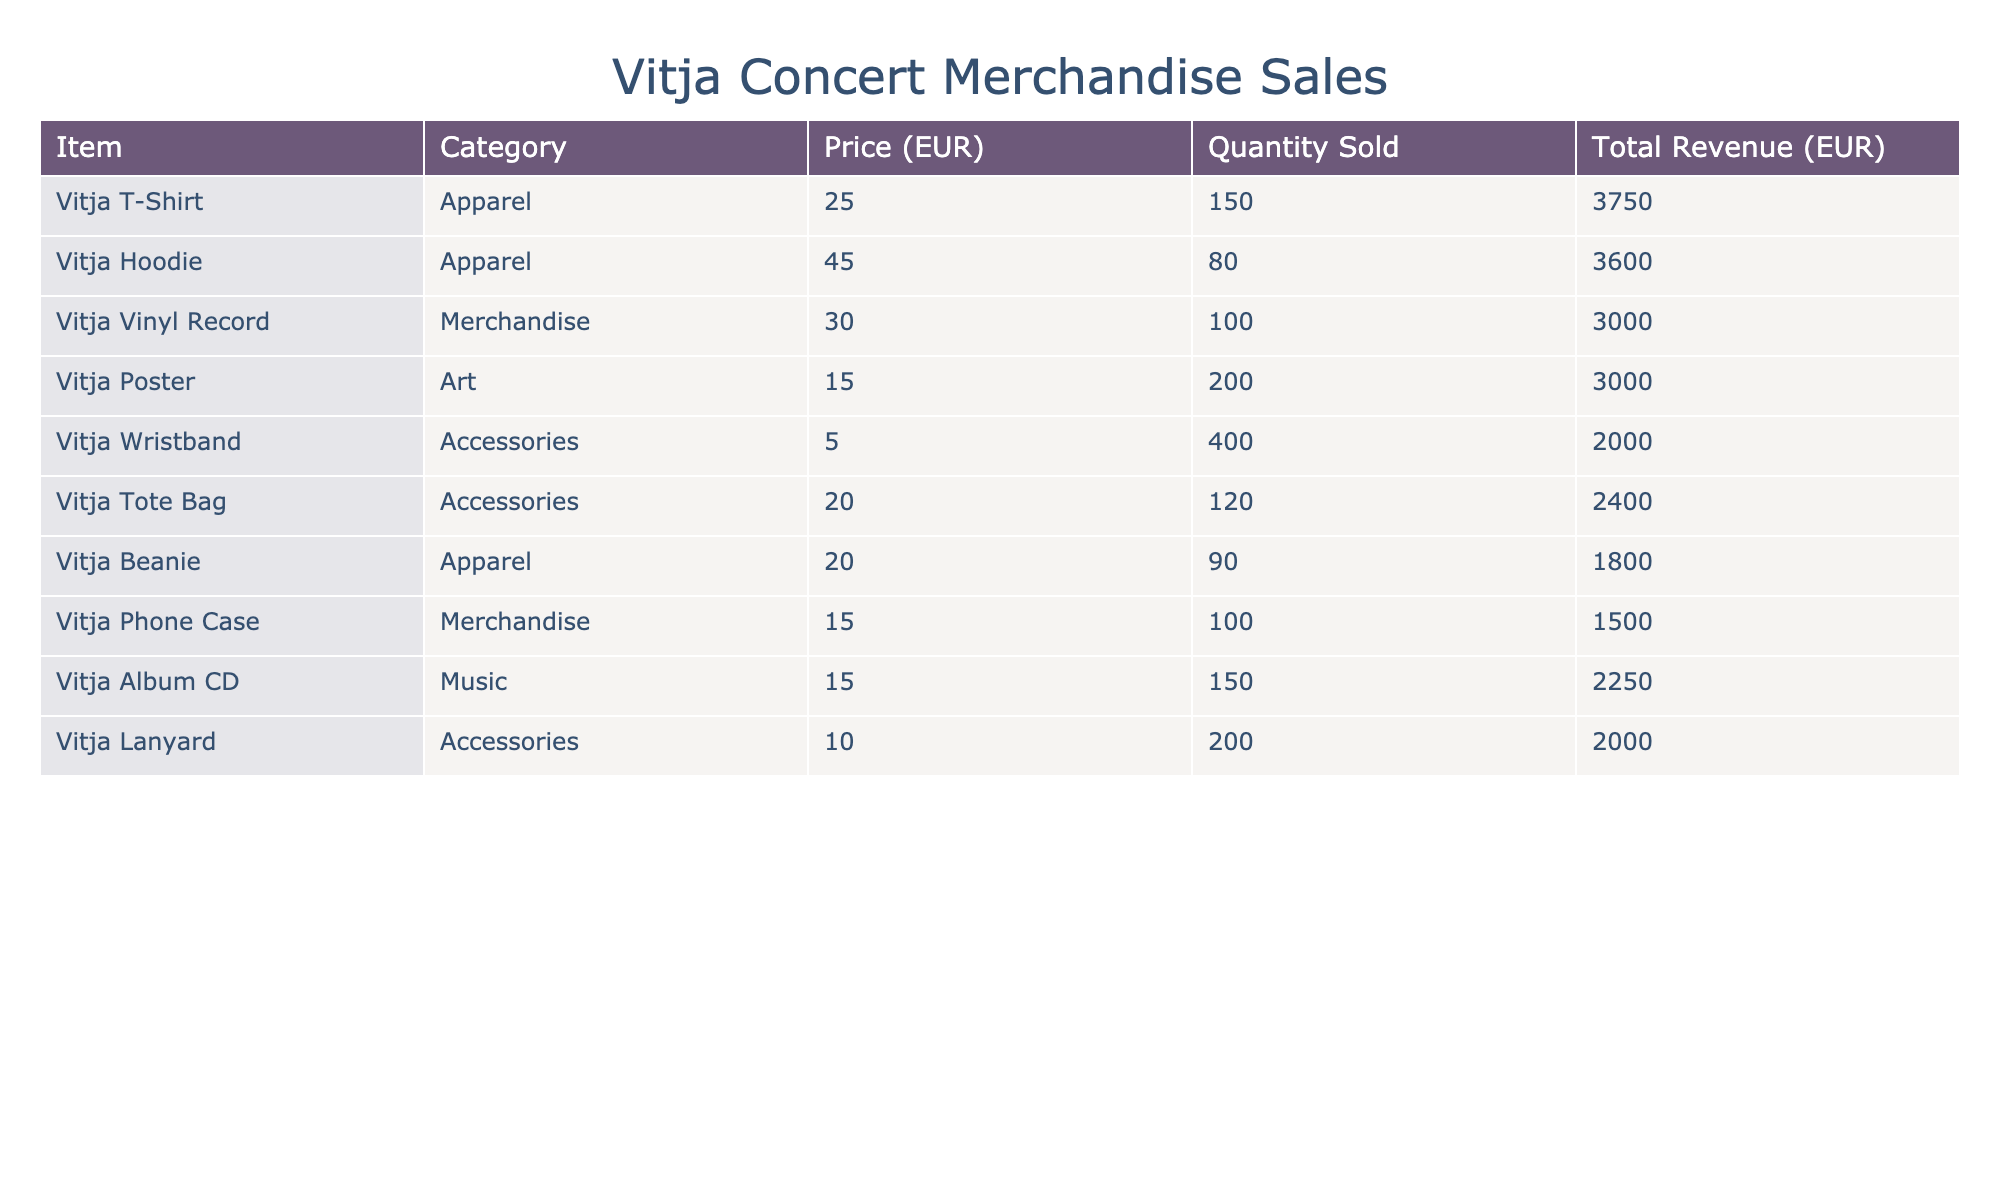What is the total revenue generated from the sale of Vitja Hoodies? The table shows that the quantity sold for Vitja Hoodies is 80 and the price per hoodie is 45 EUR. To calculate the total revenue: 80 x 45 = 3600 EUR.
Answer: 3600 EUR Which merchandise item had the highest quantity sold? By examining the quantity sold, the Vitja Wristband has the highest quantity at 400.
Answer: Vitja Wristband What is the total revenue from all Accessories sold? The revenue from Accessories items are: Vitja Wristband (2000 EUR), Vitja Tote Bag (2400 EUR), and Vitja Lanyard (2000 EUR). Adding them together: 2000 + 2400 + 2000 = 6400 EUR.
Answer: 6400 EUR Did the sales of Vitja Vinyl Records exceed the sales of Vitja Phone Cases? The total revenue from the sales of Vitja Vinyl Records is 3000 EUR, and for Vitja Phone Cases it is 1500 EUR. Since 3000 > 1500, therefore the sales of Vinyl Records did exceed those of Phone Cases.
Answer: Yes What is the average price of the Apparel items sold? The Apparel items in the table are: Vitja T-Shirt (25 EUR), Vitja Hoodie (45 EUR), and Vitja Beanie (20 EUR). The total price is 25 + 45 + 20 = 90 EUR. The average price is calculated as 90 / 3 = 30 EUR.
Answer: 30 EUR How much revenue was generated from the sale of Art merchandise? The only Art merchandise listed is the Vitja Poster, which has a total revenue of 3000 EUR from the sales of 200 posters at 15 EUR each.
Answer: 3000 EUR Which category had the lowest total revenue, and what was that amount? The total revenue for each category can be checked by calculating them. The lowest is Accessories with a total of 6400 EUR (2000 + 2400 + 2000), but comparing to others, Merchandise (3000) is lower, so it is the lowest category.
Answer: Merchandise, 3000 EUR If all categories' revenues were to be summed, what would the total revenue be? The total revenues from all categories are: 3750 (Apparel) + 3600 (Apparel) + 3000 (Merchandise) + 3000 (Art) + 2000 (Accessories) + 2400 (Accessories) + 1800 (Apparel) + 1500 (Merchandise) + 2250 (Music) + 2000 (Accessories) = 26500 EUR. Thus the total revenue is 26500 EUR.
Answer: 26500 EUR How many more units of Vitja Wristbands were sold compared to Vitja Beanies? The Quantity sold for Vitja Wristbands is 400 and for Vitja Beanies is 90. To find the difference: 400 - 90 = 310 more units of Wristbands sold.
Answer: 310 